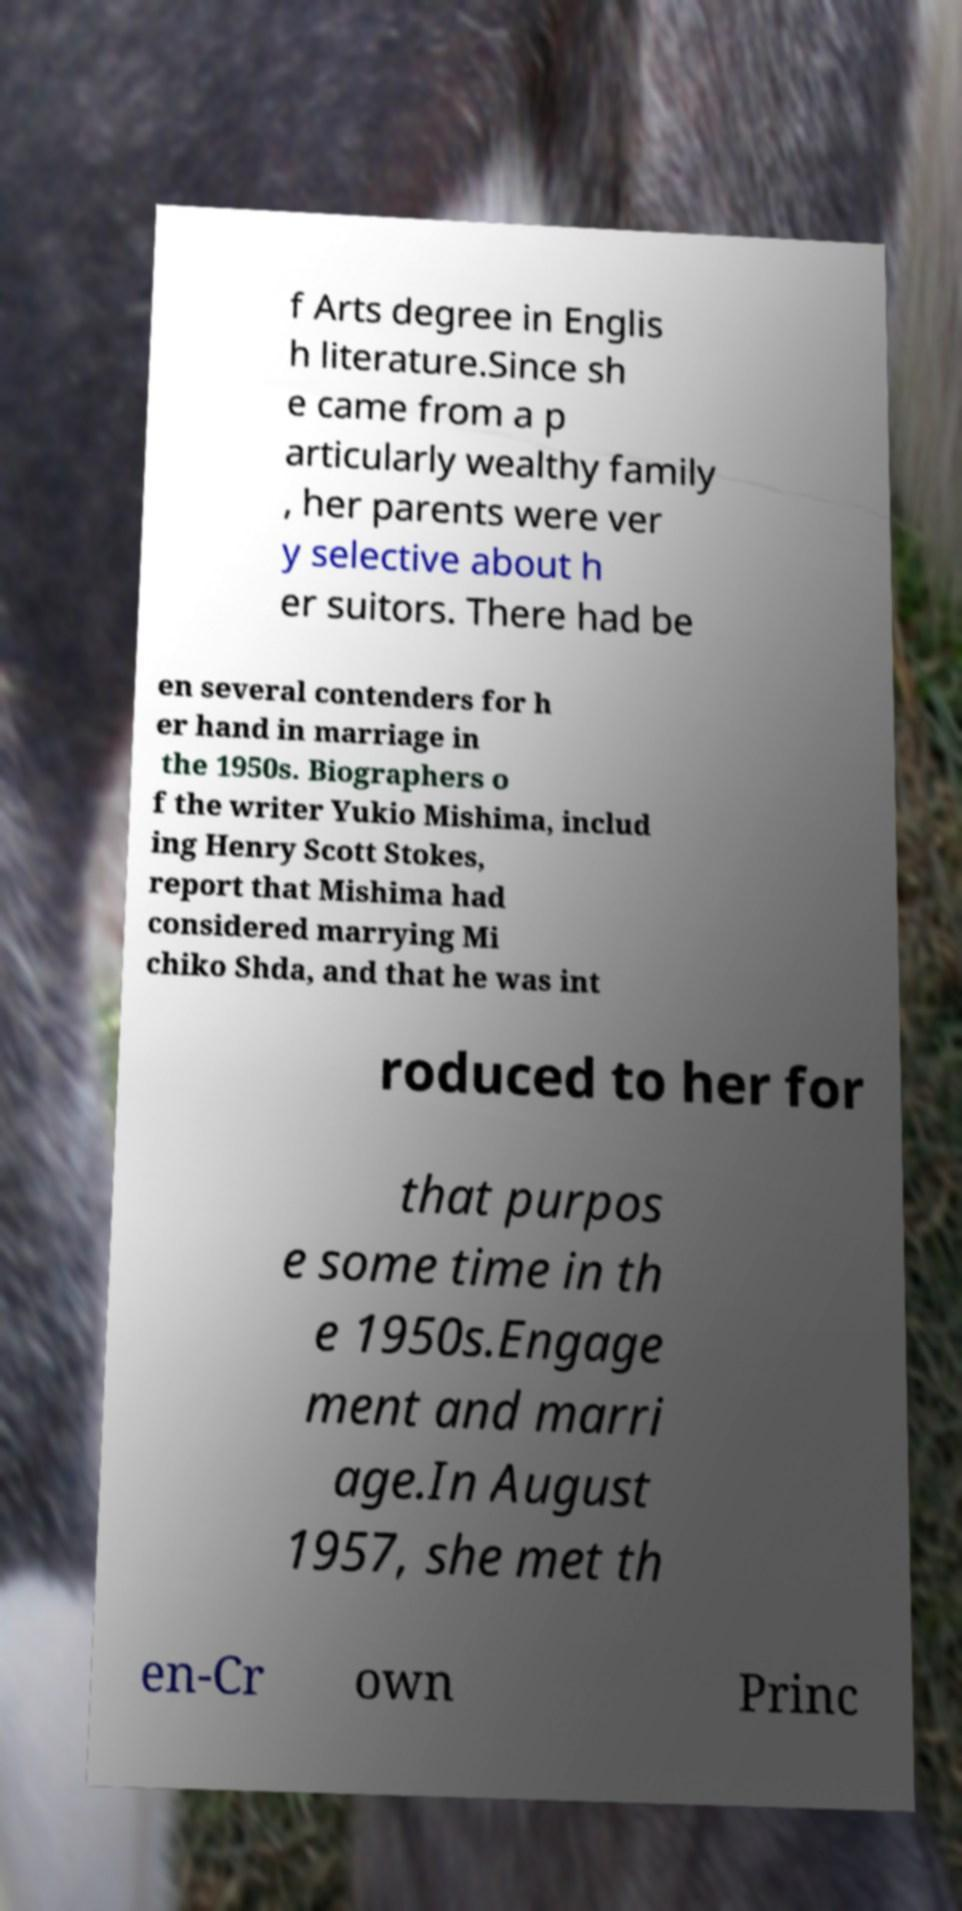Please identify and transcribe the text found in this image. f Arts degree in Englis h literature.Since sh e came from a p articularly wealthy family , her parents were ver y selective about h er suitors. There had be en several contenders for h er hand in marriage in the 1950s. Biographers o f the writer Yukio Mishima, includ ing Henry Scott Stokes, report that Mishima had considered marrying Mi chiko Shda, and that he was int roduced to her for that purpos e some time in th e 1950s.Engage ment and marri age.In August 1957, she met th en-Cr own Princ 